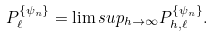Convert formula to latex. <formula><loc_0><loc_0><loc_500><loc_500>P ^ { \{ \psi _ { n } \} } _ { \ell } = \lim s u p _ { h \rightarrow \infty } P ^ { \{ \psi _ { n } \} } _ { h , \ell } .</formula> 